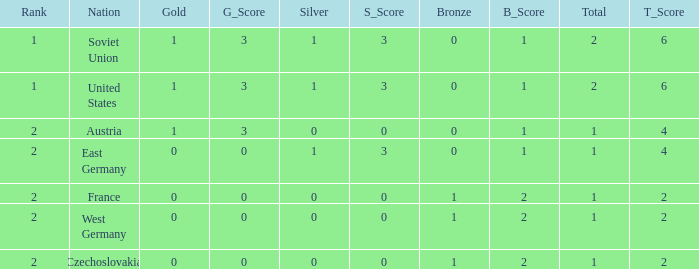I'm looking to parse the entire table for insights. Could you assist me with that? {'header': ['Rank', 'Nation', 'Gold', 'G_Score', 'Silver', 'S_Score', 'Bronze', 'B_Score', 'Total', 'T_Score'], 'rows': [['1', 'Soviet Union', '1', '3', '1', '3', '0', '1', '2', '6'], ['1', 'United States', '1', '3', '1', '3', '0', '1', '2', '6'], ['2', 'Austria', '1', '3', '0', '0', '0', '1', '1', '4'], ['2', 'East Germany', '0', '0', '1', '3', '0', '1', '1', '4'], ['2', 'France', '0', '0', '0', '0', '1', '2', '1', '2'], ['2', 'West Germany', '0', '0', '0', '0', '1', '2', '1', '2'], ['2', 'Czechoslovakia', '0', '0', '0', '0', '1', '2', '1', '2']]} What is the total number of bronze medals of West Germany, which is ranked 2 and has less than 1 total medals? 0.0. 